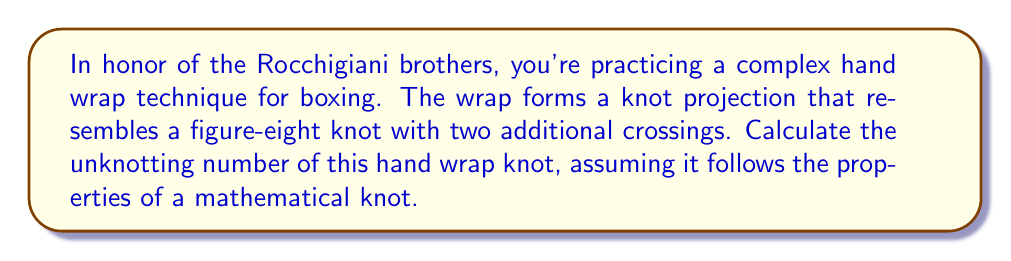Could you help me with this problem? Let's approach this step-by-step:

1) First, recall that the unknotting number of a knot is the minimum number of crossing changes required to transform the knot into an unknot (trivial knot).

2) The figure-eight knot, also known as the $4_1$ knot in knot theory, has an unknotting number of 1.

3) Our hand wrap knot is described as a figure-eight knot with two additional crossings. Let's represent this mathematically:

   $$K = 4_1 + 2$$

   where $K$ is our hand wrap knot, $4_1$ is the figure-eight knot, and +2 represents the two additional crossings.

4) The unknotting number has the following property for composite knots:

   $$u(K_1 \# K_2) \leq u(K_1) + u(K_2)$$

   where $\#$ denotes the connected sum of knots.

5) In our case, we can consider our knot as a composite of the figure-eight knot and a knot with two crossings:

   $$u(K) \leq u(4_1) + u(K_2)$$

6) We know that $u(4_1) = 1$, and for a knot with two crossings, the maximum unknotting number is 1.

7) Therefore:

   $$u(K) \leq 1 + 1 = 2$$

8) However, this is an upper bound. To determine if this is actually the unknotting number, we need to consider if it's possible to unknot with just one crossing change. Given that the figure-eight knot alone requires one crossing change, and we have two additional crossings, it's not possible to unknot with just one change.

9) Thus, we can conclude that the unknotting number of our hand wrap knot is exactly 2.
Answer: 2 